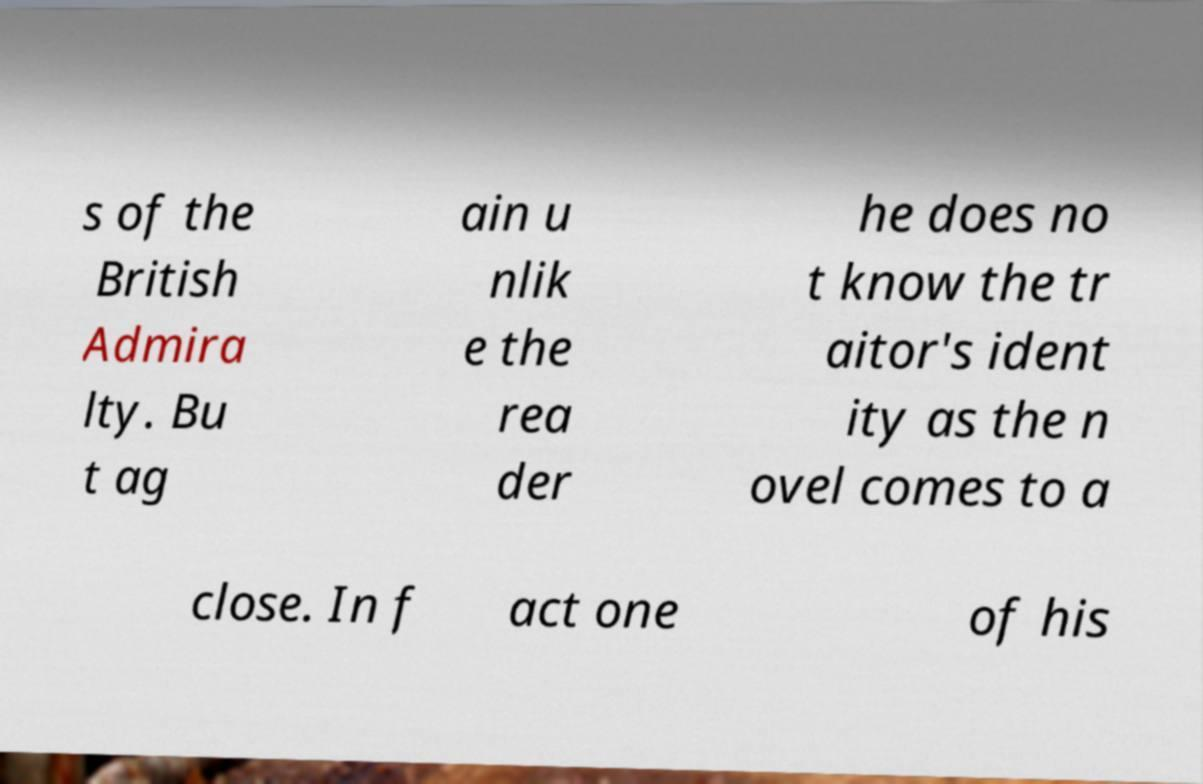Could you assist in decoding the text presented in this image and type it out clearly? s of the British Admira lty. Bu t ag ain u nlik e the rea der he does no t know the tr aitor's ident ity as the n ovel comes to a close. In f act one of his 